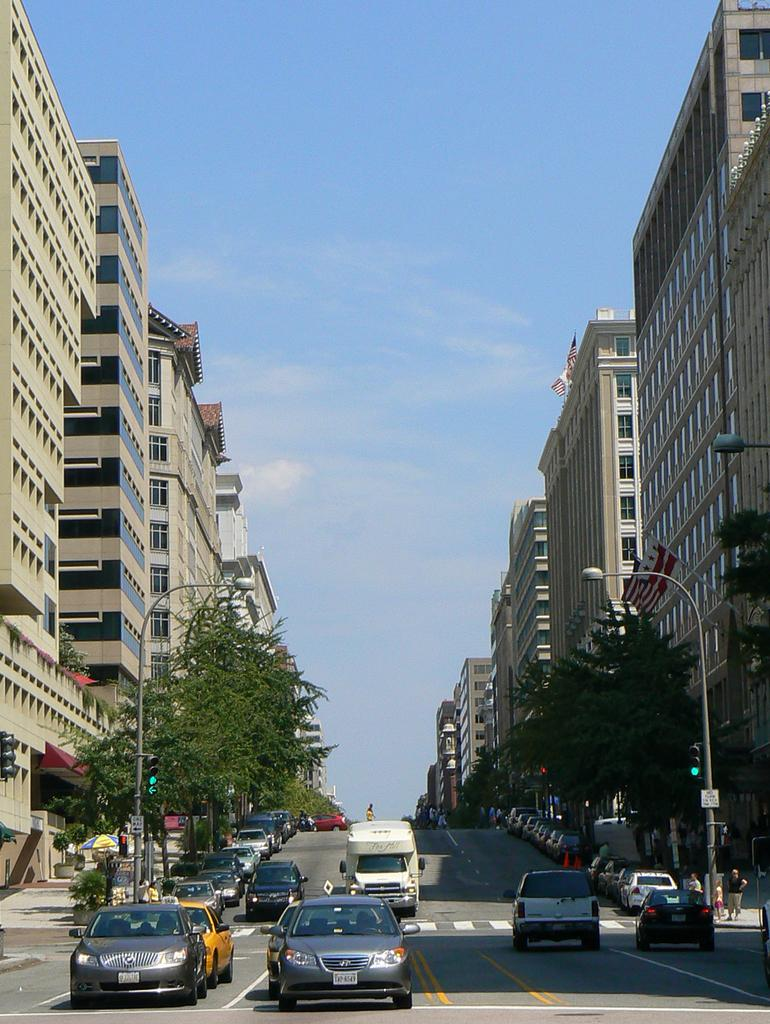What can be seen on the road in the image? There are vehicles on the road in the image. What objects are present in the image besides the vehicles? There are poles, lights, plants, trees, a traffic signal, boards, buildings, and persons visible in the image. What type of structures can be seen in the image? There are buildings in the image. What is visible in the background of the image? The sky is visible in the background of the image. What type of cracker is being used as a side dish in the image? There is no cracker present in the image, and therefore no such side dish can be observed. 